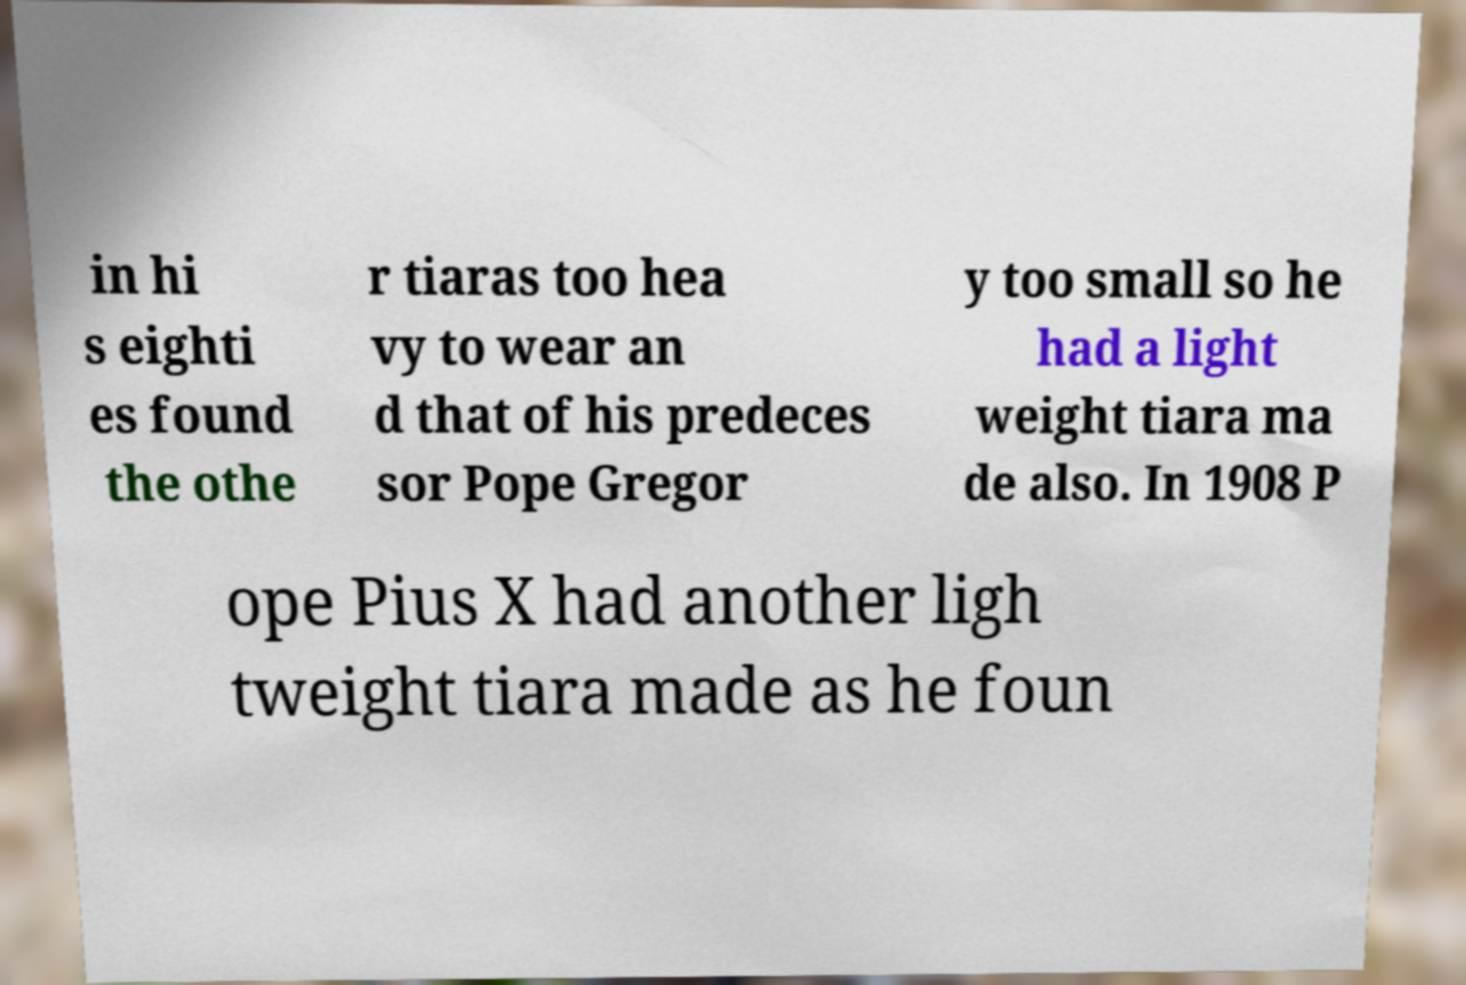Can you read and provide the text displayed in the image?This photo seems to have some interesting text. Can you extract and type it out for me? in hi s eighti es found the othe r tiaras too hea vy to wear an d that of his predeces sor Pope Gregor y too small so he had a light weight tiara ma de also. In 1908 P ope Pius X had another ligh tweight tiara made as he foun 